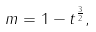Convert formula to latex. <formula><loc_0><loc_0><loc_500><loc_500>m = 1 - t ^ { \frac { 3 } { 2 } } ,</formula> 